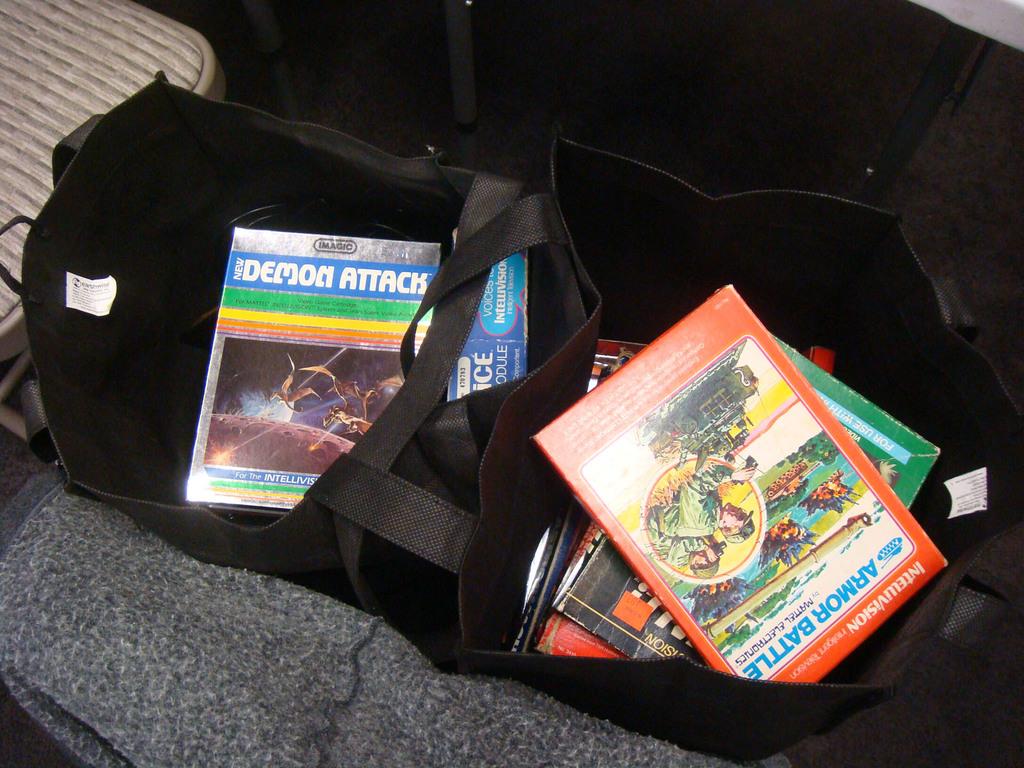What is the name of the left book?
Your response must be concise. Demon attack. 